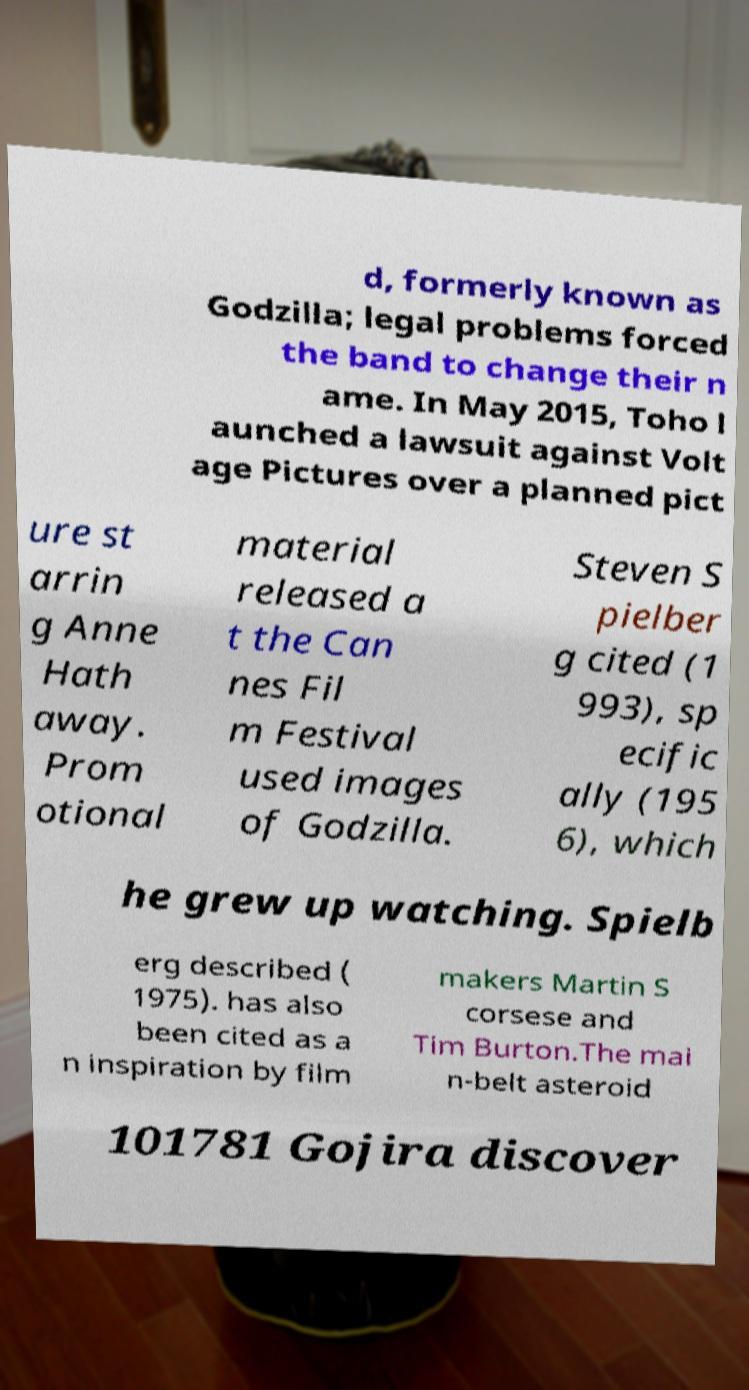Could you extract and type out the text from this image? d, formerly known as Godzilla; legal problems forced the band to change their n ame. In May 2015, Toho l aunched a lawsuit against Volt age Pictures over a planned pict ure st arrin g Anne Hath away. Prom otional material released a t the Can nes Fil m Festival used images of Godzilla. Steven S pielber g cited (1 993), sp ecific ally (195 6), which he grew up watching. Spielb erg described ( 1975). has also been cited as a n inspiration by film makers Martin S corsese and Tim Burton.The mai n-belt asteroid 101781 Gojira discover 